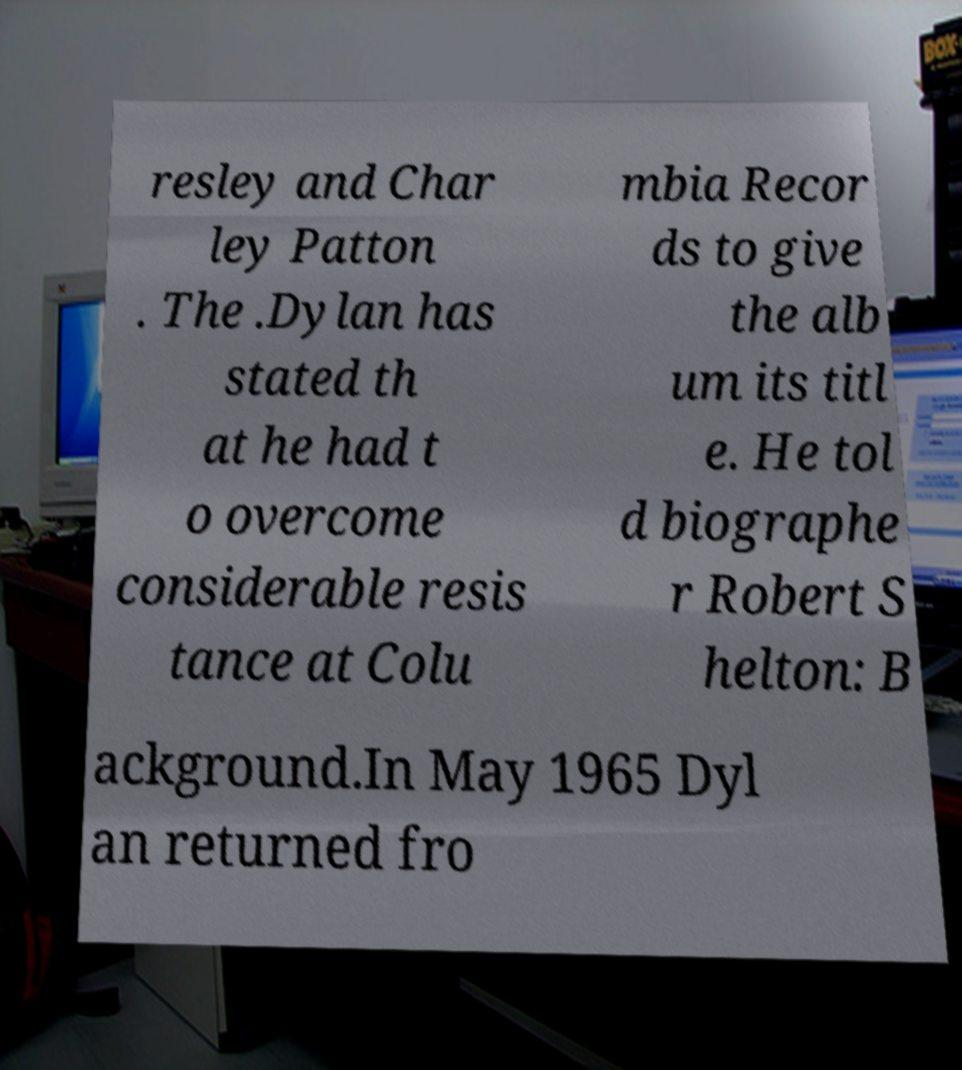What messages or text are displayed in this image? I need them in a readable, typed format. resley and Char ley Patton . The .Dylan has stated th at he had t o overcome considerable resis tance at Colu mbia Recor ds to give the alb um its titl e. He tol d biographe r Robert S helton: B ackground.In May 1965 Dyl an returned fro 